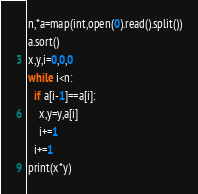Convert code to text. <code><loc_0><loc_0><loc_500><loc_500><_Python_>n,*a=map(int,open(0).read().split())
a.sort()
x,y,i=0,0,0
while i<n:
  if a[i-1]==a[i]:
    x,y=y,a[i]
    i+=1
  i+=1
print(x*y)</code> 